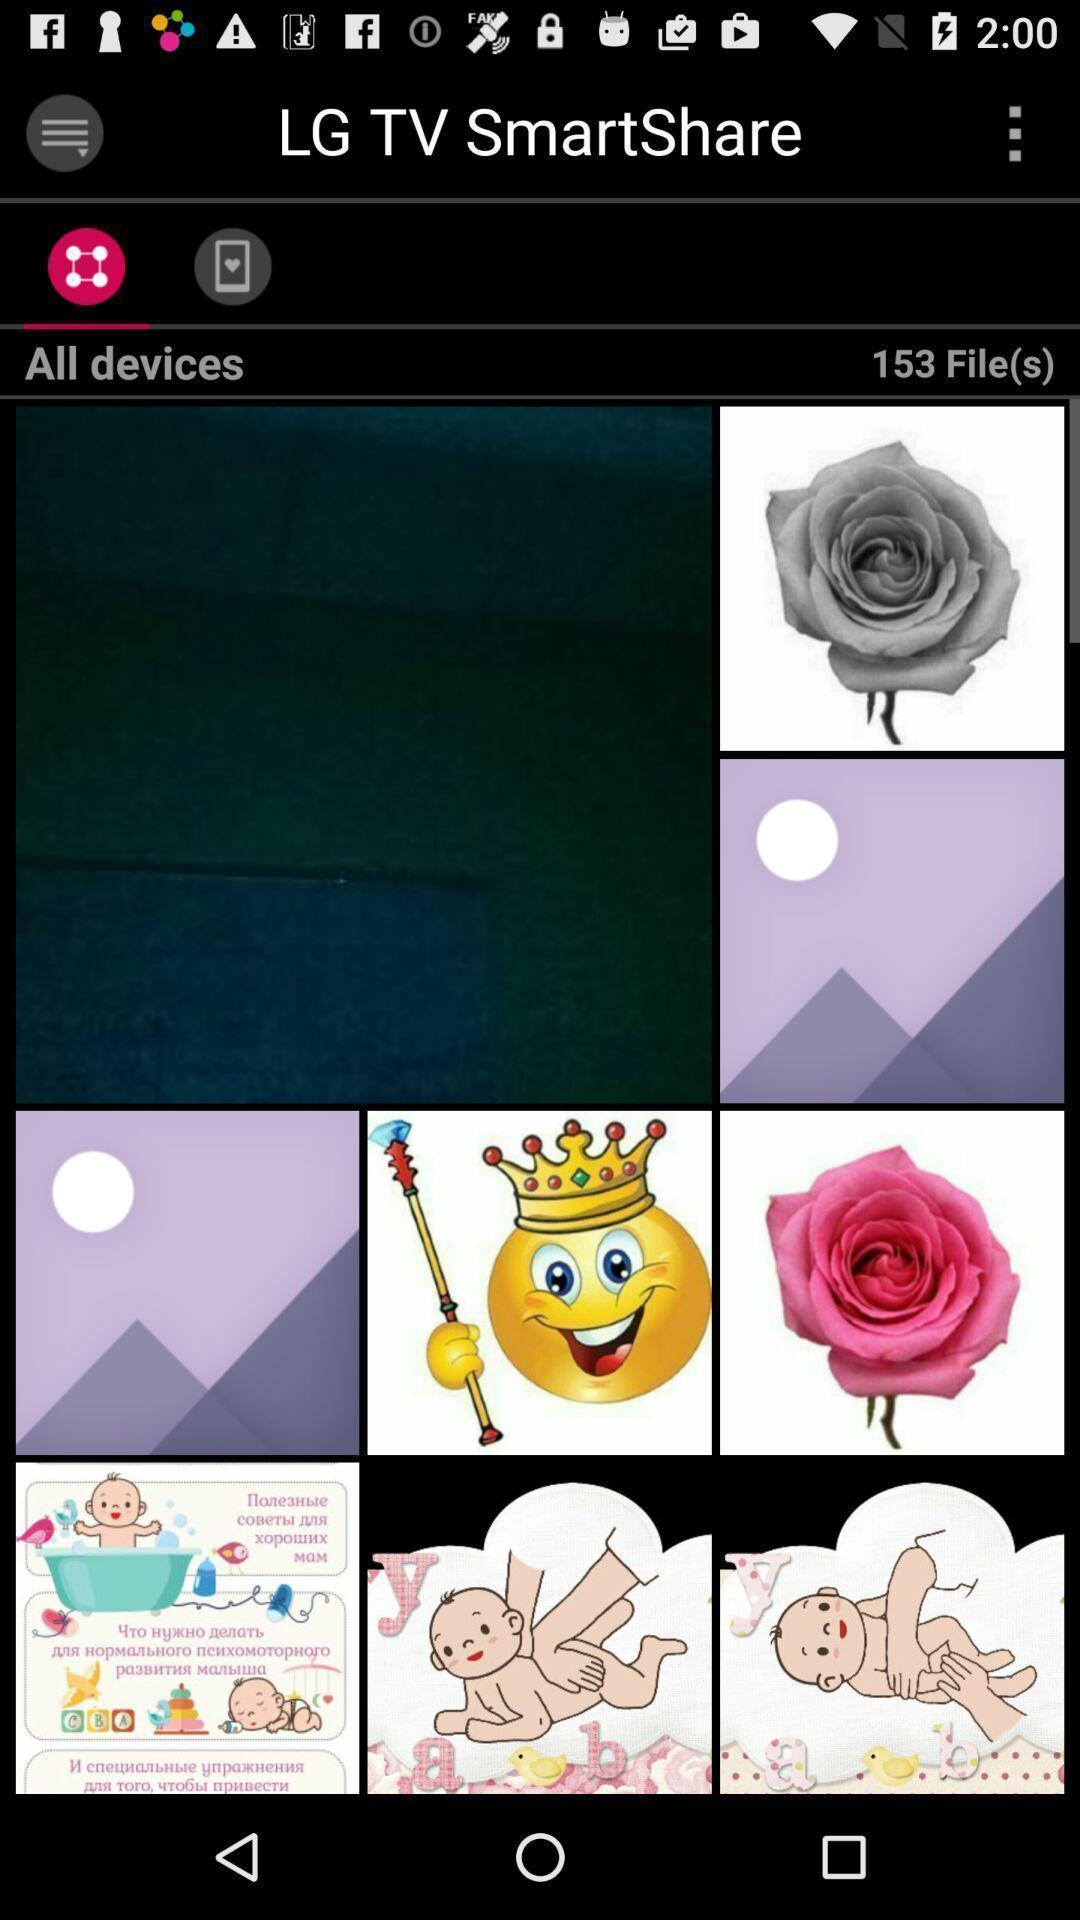Summarize the main components in this picture. Screen displaying various types of images. 